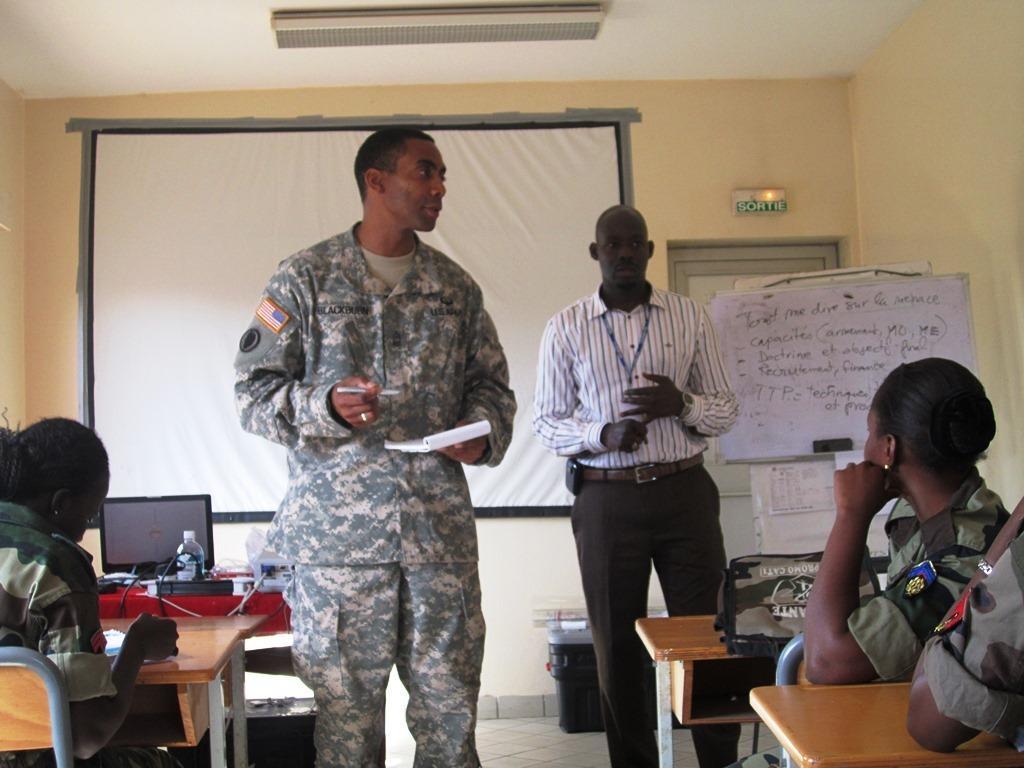Please provide a concise description of this image. In this picture there are five persons one of the man is in the uniform looks like he is in the military. He is holding a book and a pen in his hands and the other person is in his formals standing beside this person and the other three are ladies sitting on the chair and keeping the bag in front of them and a book in the background i could see a white board and to the ceiling there is bulb and in the back there is window to the wall. 